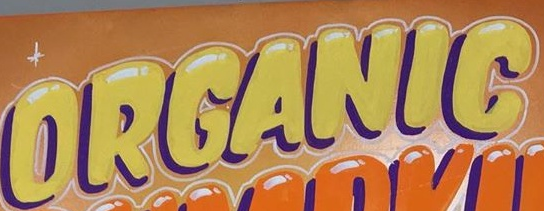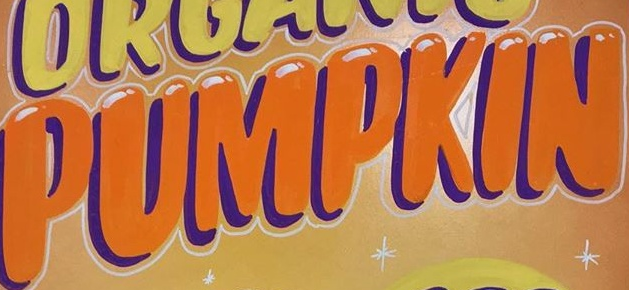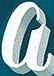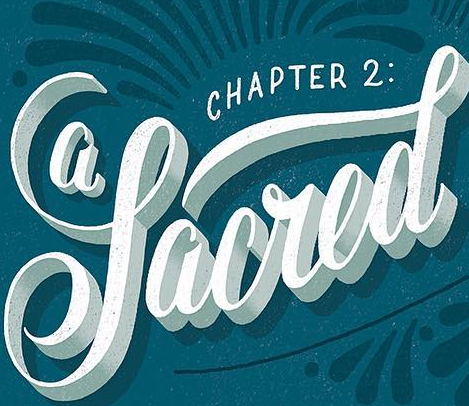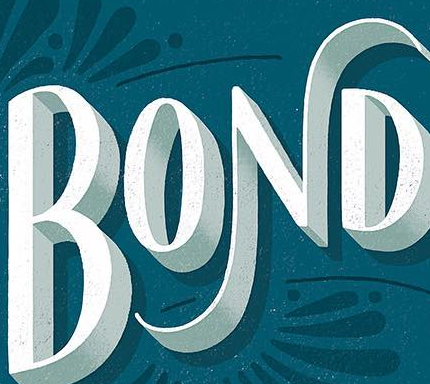What words can you see in these images in sequence, separated by a semicolon? ORGANIG; PUMPKIN; a; Sacred; BOND 